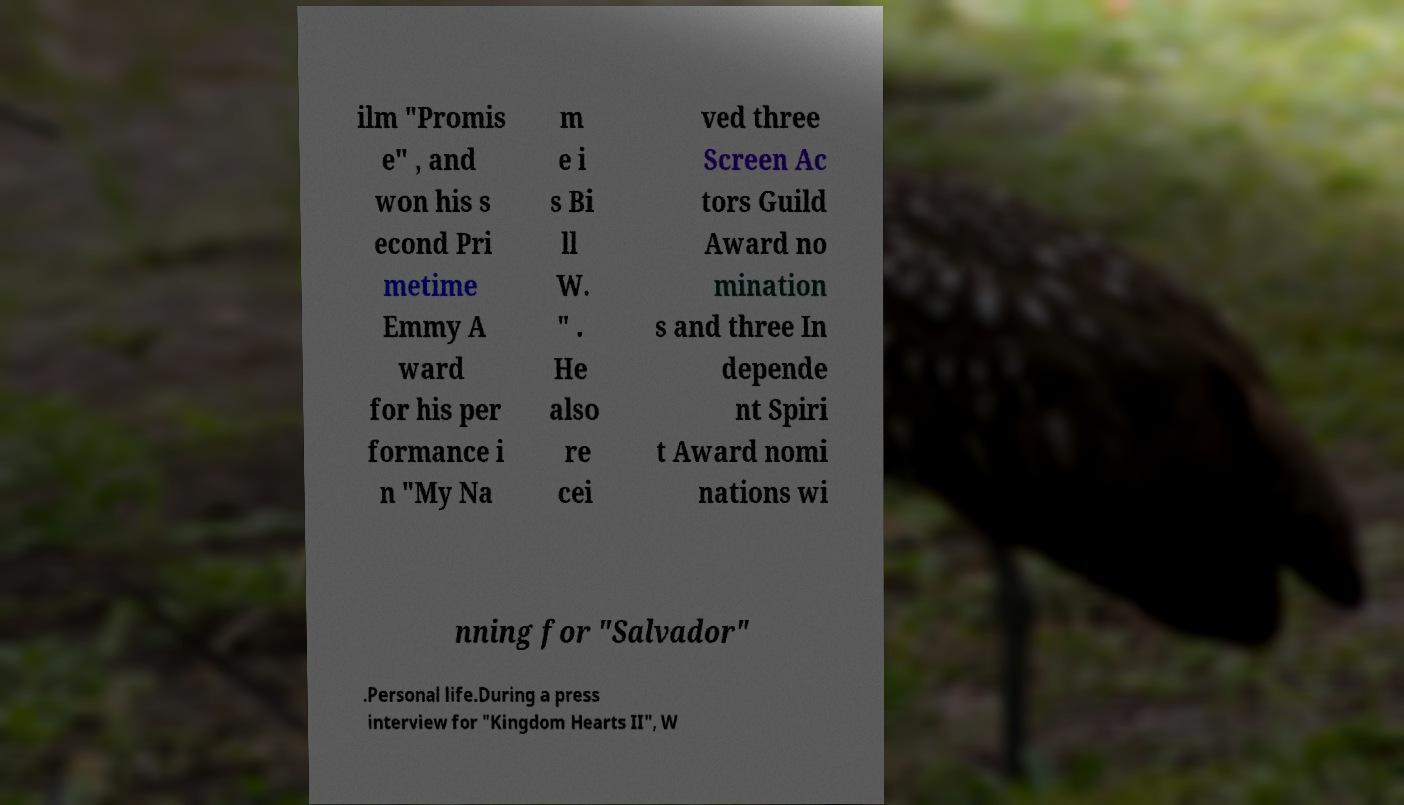Could you assist in decoding the text presented in this image and type it out clearly? ilm "Promis e" , and won his s econd Pri metime Emmy A ward for his per formance i n "My Na m e i s Bi ll W. " . He also re cei ved three Screen Ac tors Guild Award no mination s and three In depende nt Spiri t Award nomi nations wi nning for "Salvador" .Personal life.During a press interview for "Kingdom Hearts II", W 